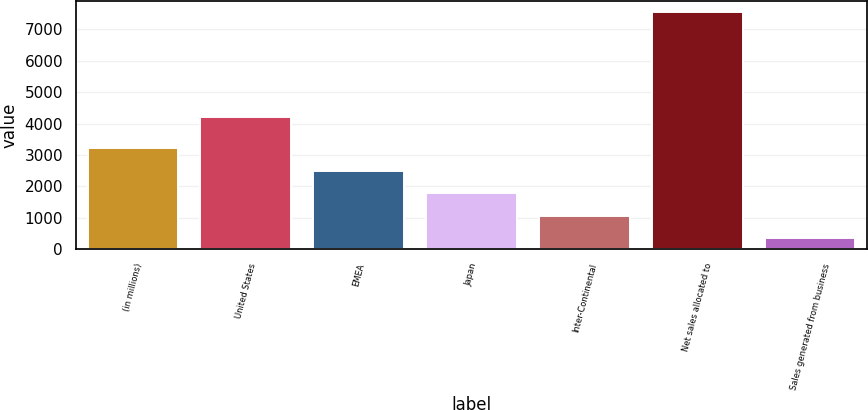<chart> <loc_0><loc_0><loc_500><loc_500><bar_chart><fcel>(in millions)<fcel>United States<fcel>EMEA<fcel>Japan<fcel>Inter-Continental<fcel>Net sales allocated to<fcel>Sales generated from business<nl><fcel>3224<fcel>4215<fcel>2504.5<fcel>1785<fcel>1065.5<fcel>7541<fcel>346<nl></chart> 